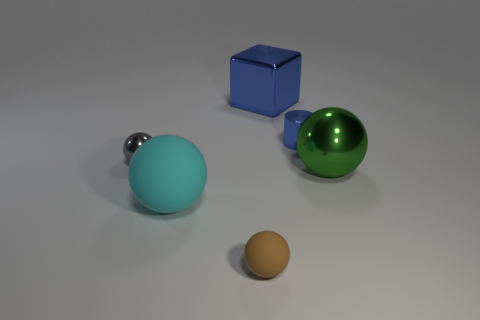There is a big cyan thing that is the same shape as the green metallic object; what is its material?
Provide a succinct answer. Rubber. What number of other brown matte objects have the same shape as the brown rubber thing?
Give a very brief answer. 0. Is the color of the large shiny object to the left of the blue shiny cylinder the same as the metallic cylinder?
Offer a terse response. Yes. There is a small shiny thing in front of the blue thing that is in front of the metallic block on the left side of the large green metal sphere; what shape is it?
Provide a succinct answer. Sphere. Does the blue cylinder have the same size as the green metallic ball that is behind the brown sphere?
Give a very brief answer. No. Is there a metal cylinder that has the same size as the blue metallic cube?
Your answer should be compact. No. How many other objects are the same material as the green sphere?
Give a very brief answer. 3. What color is the small thing that is both behind the green sphere and to the left of the tiny cylinder?
Give a very brief answer. Gray. Is the material of the large object to the right of the blue metallic block the same as the big sphere to the left of the big metallic sphere?
Provide a short and direct response. No. Does the metal ball on the right side of the gray sphere have the same size as the tiny blue object?
Your answer should be very brief. No. 